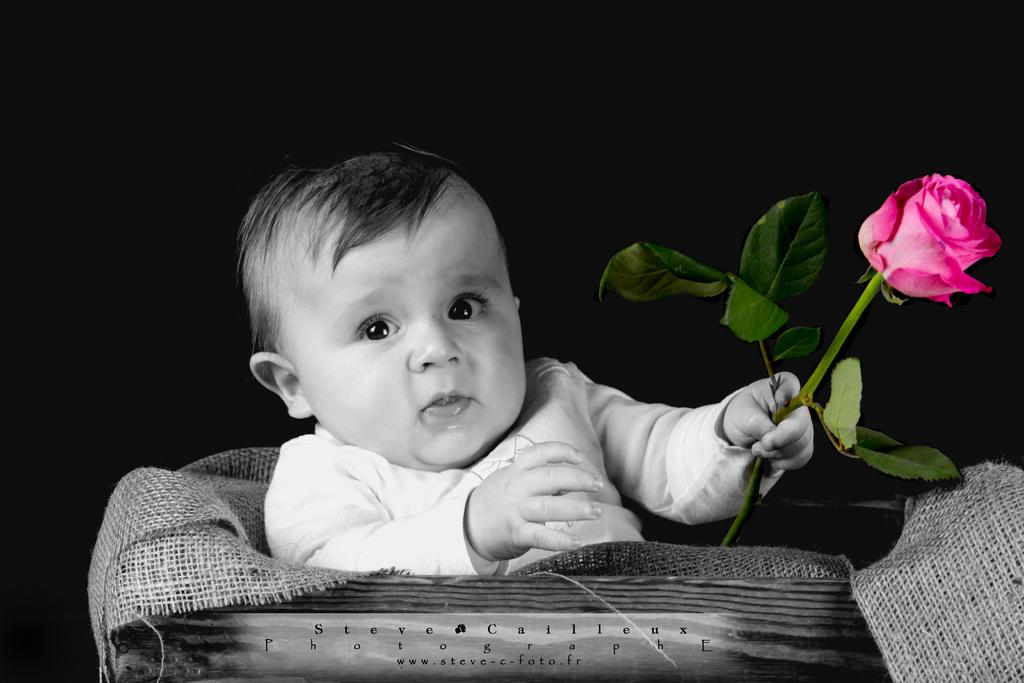What is the main subject of the image? The main subject of the image is a kid. What is the kid holding in the image? The kid is holding a rose. What type of material can be seen in the image? Jute is visible in the image. Can you describe the object with text in the image? There is an object with text in the image, but its specific details are not mentioned in the facts. What is the color of the background in the image? The background of the image is dark. What type of bird can be seen coughing in the image? There is no bird, let alone a coughing bird, present in the image. 